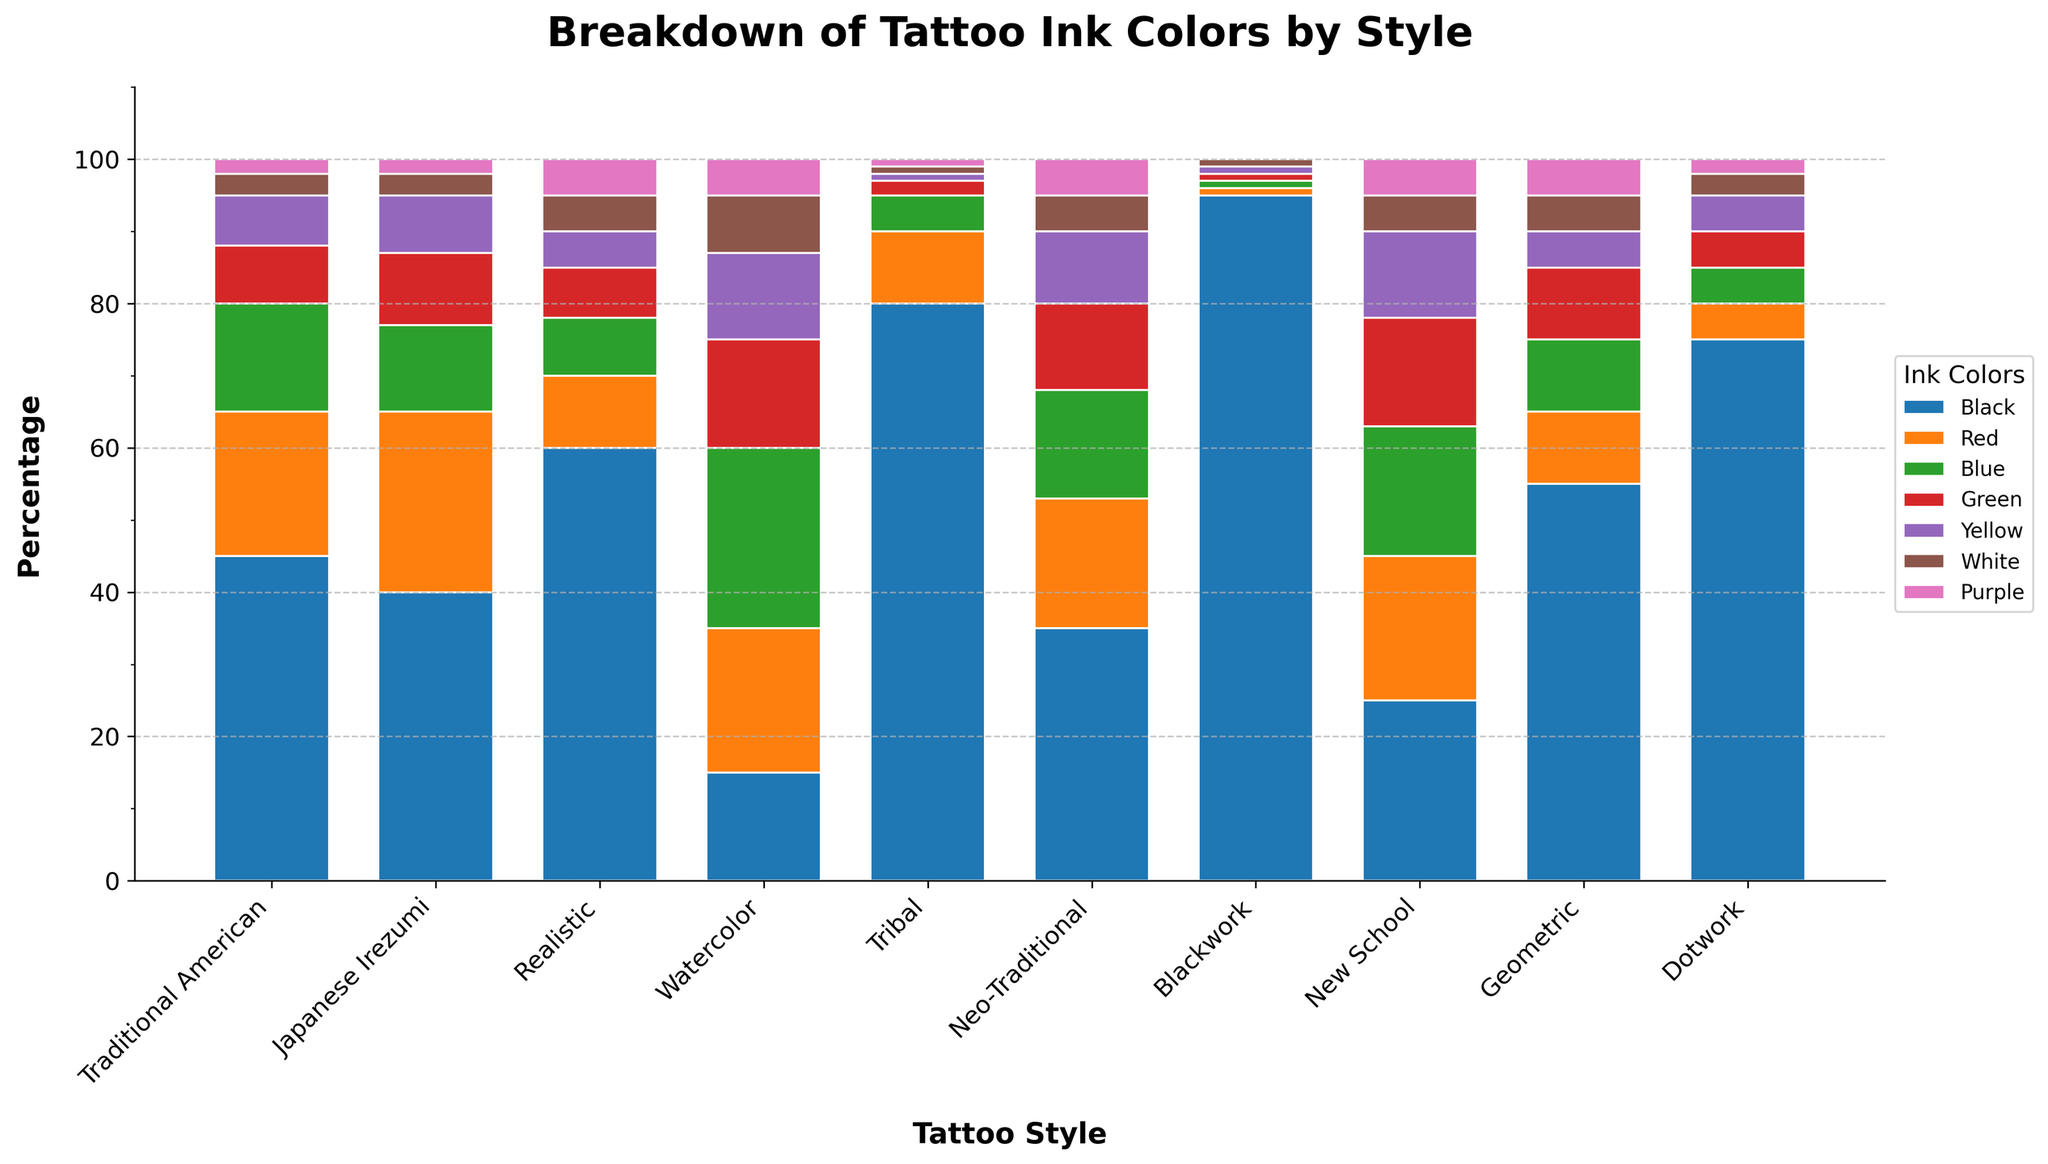What tattoo style uses the highest percentage of black ink? To determine this, scan the figure for the bar that has the largest segment in black. The "Blackwork" style has the tallest black bar segment.
Answer: Blackwork Which tattoo style has the least variation in ink colors used? Look for the style that has the fewest different color segments in its bar. “Blackwork” primarily uses black with only minimal amounts of other colors.
Answer: Blackwork Which ink color is used the least across all tattoo styles? Sum the heights of each segment for each color across all bars and compare. Purple ink has the least total height.
Answer: Purple Comparing "Traditional American" and "Japanese Irezumi", which style uses more red ink? Find the red segments for each of these styles and compare their heights. "Japanese Irezumi" uses more red ink than "Traditional American".
Answer: Japanese Irezumi How many styles use more than 50% black ink? Count the number of styles where the black segment exceeds half the bar's height. "Tribal", "Blackwork", and "Dotwork" each use more than 50% black ink.
Answer: 3 What percentage of ink used in "Watercolor" is non-black? First, find the total percentage of non-black segments in the "Watercolor" bar by summing the heights of the other colors. Subtract 15% (height of black ink) from 100%.
Answer: 85% Which ink color is most commonly used in "Neo-Traditional" style? Identify the color segment with the greatest height in the "Neo-Traditional" bar. Black is the dominant color.
Answer: Black For the "Realistic" style, do green and yellow inks together account for more or less than the total red ink used? Add the heights of green (7%) and yellow (5%) ink segments and compare to red (10%). Green and yellow together sum to 12%, which is more than 10% red ink.
Answer: More Which two tattoo styles have the most similar distribution of ink colors? Visually compare the segment heights of each color between all styles to find the closest match. "Traditional American" and "Neo-Traditional" have very similar color distributions.
Answer: Traditional American and Neo-Traditional What is the total percentage of white ink used across all tattoo styles? Add the heights of the white segments from all styles: 3 + 3 + 5 + 8 + 1 + 5 + 1 + 5 + 5 + 3 = 39%.
Answer: 39% 